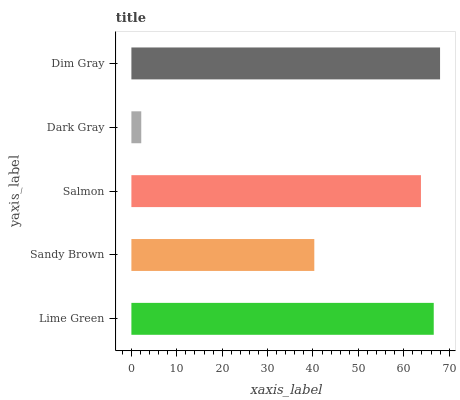Is Dark Gray the minimum?
Answer yes or no. Yes. Is Dim Gray the maximum?
Answer yes or no. Yes. Is Sandy Brown the minimum?
Answer yes or no. No. Is Sandy Brown the maximum?
Answer yes or no. No. Is Lime Green greater than Sandy Brown?
Answer yes or no. Yes. Is Sandy Brown less than Lime Green?
Answer yes or no. Yes. Is Sandy Brown greater than Lime Green?
Answer yes or no. No. Is Lime Green less than Sandy Brown?
Answer yes or no. No. Is Salmon the high median?
Answer yes or no. Yes. Is Salmon the low median?
Answer yes or no. Yes. Is Sandy Brown the high median?
Answer yes or no. No. Is Dim Gray the low median?
Answer yes or no. No. 